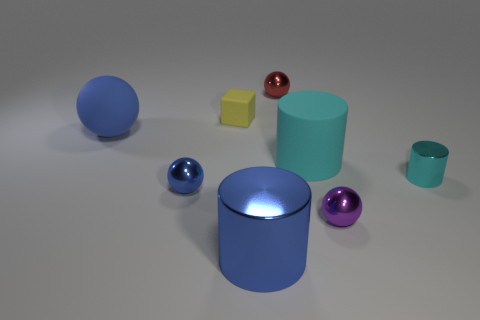Add 1 tiny shiny blocks. How many objects exist? 9 Subtract all blocks. How many objects are left? 7 Subtract 0 cyan blocks. How many objects are left? 8 Subtract all cylinders. Subtract all small red objects. How many objects are left? 4 Add 8 small cyan cylinders. How many small cyan cylinders are left? 9 Add 6 yellow matte blocks. How many yellow matte blocks exist? 7 